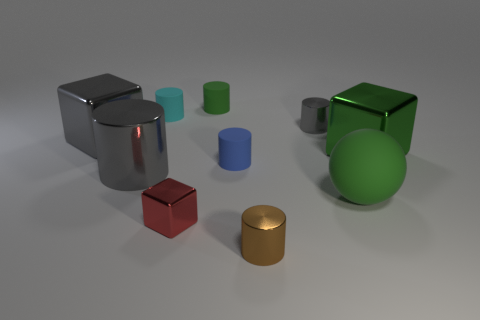How many tiny matte things are to the right of the large shiny cube behind the big green metallic thing that is behind the red metal thing?
Your answer should be compact. 3. Does the blue object have the same shape as the large green thing that is behind the green sphere?
Give a very brief answer. No. Is the number of large blue shiny spheres greater than the number of blocks?
Offer a terse response. No. Are there any other things that have the same size as the blue rubber cylinder?
Make the answer very short. Yes. There is a big shiny object that is behind the green metallic object; does it have the same shape as the tiny cyan rubber object?
Your answer should be very brief. No. Are there more brown metallic things to the right of the big green metallic object than large gray shiny cylinders?
Offer a terse response. No. What is the color of the shiny cylinder that is in front of the large gray metallic object in front of the blue thing?
Your answer should be very brief. Brown. How many purple metal balls are there?
Offer a very short reply. 0. How many objects are behind the big gray cylinder and left of the green matte sphere?
Provide a succinct answer. 5. Are there any other things that are the same shape as the tiny green matte object?
Keep it short and to the point. Yes. 